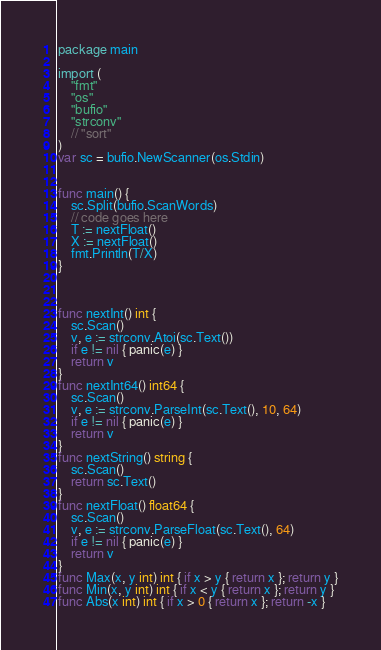Convert code to text. <code><loc_0><loc_0><loc_500><loc_500><_Go_>package main

import (
    "fmt"
    "os"
    "bufio"
    "strconv"
    // "sort"
)
var sc = bufio.NewScanner(os.Stdin)


func main() {
    sc.Split(bufio.ScanWords)
    // code goes here
    T := nextFloat()
    X := nextFloat()
    fmt.Println(T/X)
}



func nextInt() int {
    sc.Scan()
    v, e := strconv.Atoi(sc.Text())
    if e != nil { panic(e) }
    return v
}
func nextInt64() int64 {
    sc.Scan()
    v, e := strconv.ParseInt(sc.Text(), 10, 64)
    if e != nil { panic(e) }
    return v
}
func nextString() string {
    sc.Scan()
    return sc.Text()
}
func nextFloat() float64 {
    sc.Scan()
    v, e := strconv.ParseFloat(sc.Text(), 64)
    if e != nil { panic(e) }
    return v
}
func Max(x, y int) int { if x > y { return x }; return y }
func Min(x, y int) int { if x < y { return x }; return y }
func Abs(x int) int { if x > 0 { return x }; return -x }
</code> 